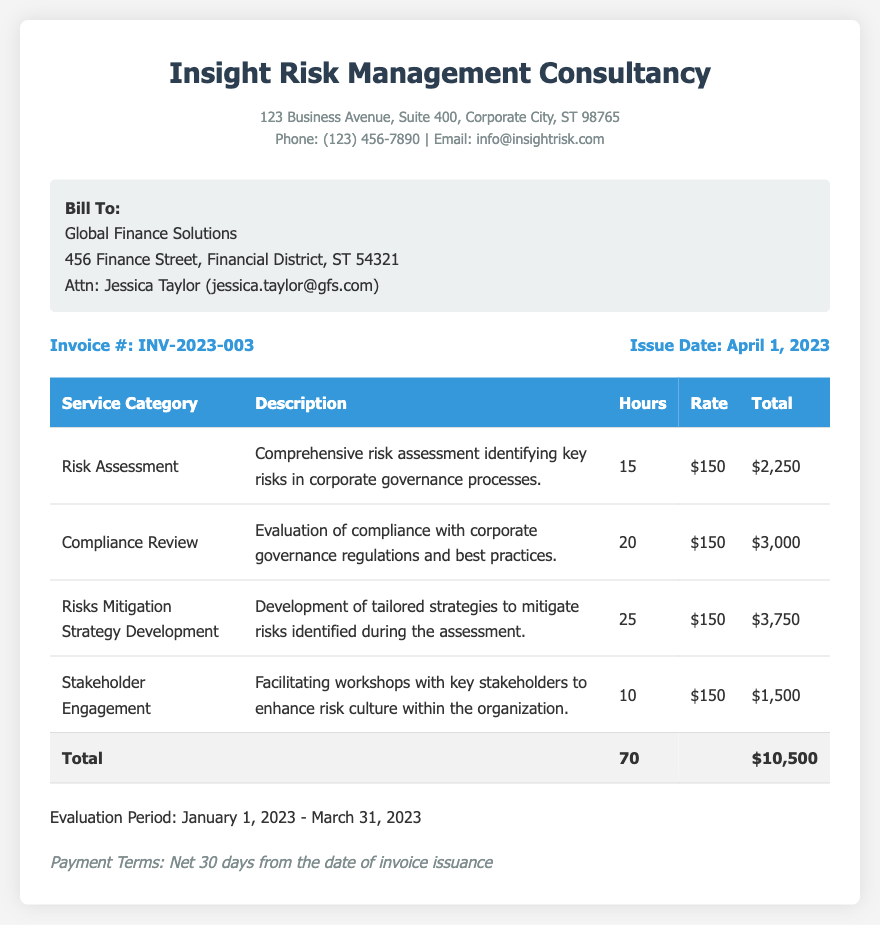What is the invoice number? The invoice number is displayed prominently in the invoice details section of the document.
Answer: INV-2023-003 What is the issue date of this invoice? The issue date is located next to the invoice number in the document, indicating when the invoice was generated.
Answer: April 1, 2023 How many total hours were billed? The total hours are calculated and displayed in the total row of the services table.
Answer: 70 What is the total amount billed? The total amount is shown in the total row at the bottom of the table, summarizing all services rendered.
Answer: $10,500 Which service category had the highest billed hours? The service category with the highest hours can be inferred from the service details table.
Answer: Risks Mitigation Strategy Development What is the evaluation period for the services rendered? The evaluation period is clearly stated in the document, specifying the time frame during which services were provided.
Answer: January 1, 2023 - March 31, 2023 Who is the client for this invoice? The client's name and contact information are provided in the client info section of the document.
Answer: Global Finance Solutions What are the payment terms specified in the document? The payment terms are mentioned at the bottom of the document, outlining the expected payment schedule.
Answer: Net 30 days from the date of invoice issuance 